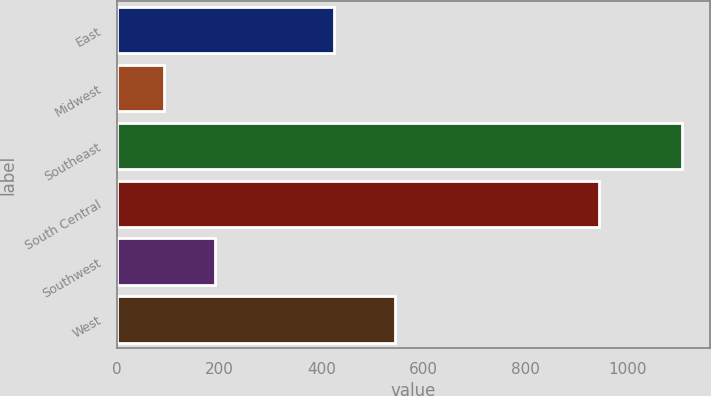Convert chart. <chart><loc_0><loc_0><loc_500><loc_500><bar_chart><fcel>East<fcel>Midwest<fcel>Southeast<fcel>South Central<fcel>Southwest<fcel>West<nl><fcel>425.4<fcel>91.6<fcel>1105.9<fcel>942.5<fcel>193.03<fcel>544.7<nl></chart> 